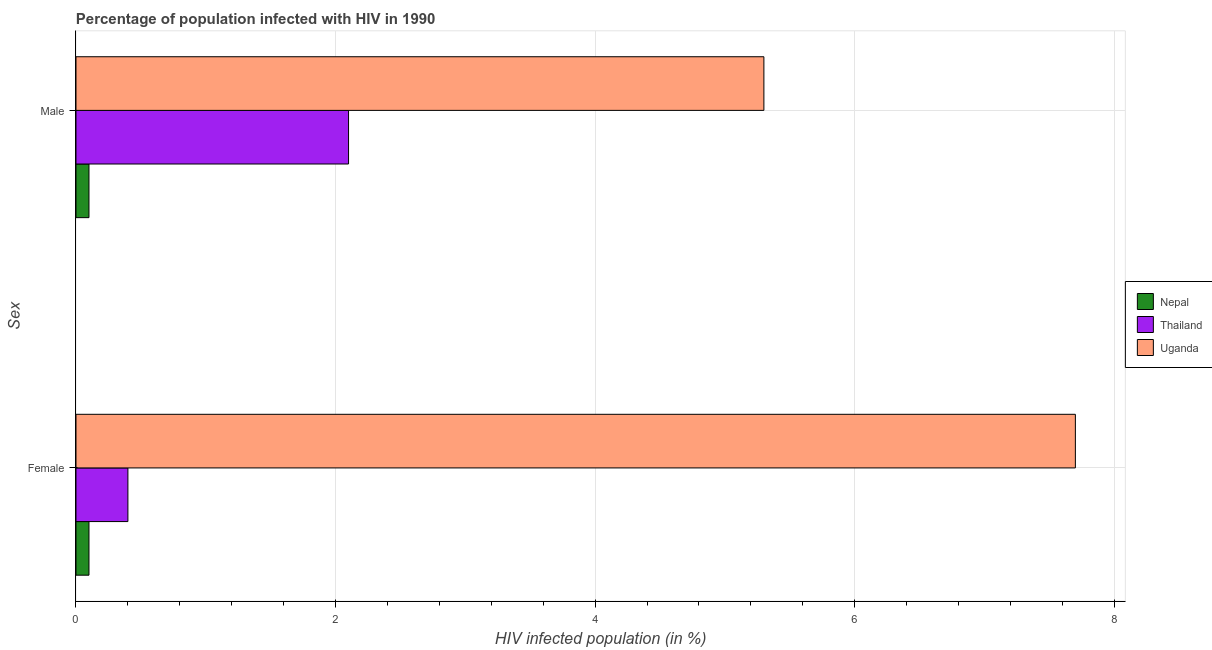What is the percentage of males who are infected with hiv in Thailand?
Your answer should be very brief. 2.1. In which country was the percentage of males who are infected with hiv maximum?
Offer a very short reply. Uganda. In which country was the percentage of females who are infected with hiv minimum?
Make the answer very short. Nepal. What is the total percentage of males who are infected with hiv in the graph?
Provide a succinct answer. 7.5. What is the difference between the percentage of males who are infected with hiv in Uganda and that in Thailand?
Provide a short and direct response. 3.2. What is the difference between the percentage of males who are infected with hiv in Nepal and the percentage of females who are infected with hiv in Uganda?
Keep it short and to the point. -7.6. What is the difference between the percentage of females who are infected with hiv and percentage of males who are infected with hiv in Uganda?
Your answer should be compact. 2.4. What is the ratio of the percentage of males who are infected with hiv in Thailand to that in Uganda?
Provide a short and direct response. 0.4. What does the 2nd bar from the top in Female represents?
Offer a terse response. Thailand. What does the 2nd bar from the bottom in Male represents?
Make the answer very short. Thailand. How many bars are there?
Keep it short and to the point. 6. What is the difference between two consecutive major ticks on the X-axis?
Provide a succinct answer. 2. Does the graph contain any zero values?
Your answer should be compact. No. Where does the legend appear in the graph?
Your response must be concise. Center right. How many legend labels are there?
Offer a terse response. 3. How are the legend labels stacked?
Keep it short and to the point. Vertical. What is the title of the graph?
Make the answer very short. Percentage of population infected with HIV in 1990. Does "Bhutan" appear as one of the legend labels in the graph?
Provide a succinct answer. No. What is the label or title of the X-axis?
Provide a succinct answer. HIV infected population (in %). What is the label or title of the Y-axis?
Offer a very short reply. Sex. What is the HIV infected population (in %) in Thailand in Female?
Offer a terse response. 0.4. What is the HIV infected population (in %) of Nepal in Male?
Provide a succinct answer. 0.1. Across all Sex, what is the maximum HIV infected population (in %) of Uganda?
Keep it short and to the point. 7.7. Across all Sex, what is the minimum HIV infected population (in %) in Thailand?
Provide a succinct answer. 0.4. What is the total HIV infected population (in %) in Thailand in the graph?
Provide a short and direct response. 2.5. What is the total HIV infected population (in %) in Uganda in the graph?
Offer a very short reply. 13. What is the difference between the HIV infected population (in %) in Nepal in Female and that in Male?
Offer a very short reply. 0. What is the difference between the HIV infected population (in %) in Thailand in Female and the HIV infected population (in %) in Uganda in Male?
Ensure brevity in your answer.  -4.9. What is the average HIV infected population (in %) in Uganda per Sex?
Keep it short and to the point. 6.5. What is the difference between the HIV infected population (in %) of Nepal and HIV infected population (in %) of Thailand in Female?
Your response must be concise. -0.3. What is the difference between the HIV infected population (in %) of Thailand and HIV infected population (in %) of Uganda in Female?
Offer a very short reply. -7.3. What is the difference between the HIV infected population (in %) of Nepal and HIV infected population (in %) of Thailand in Male?
Your answer should be compact. -2. What is the difference between the HIV infected population (in %) in Nepal and HIV infected population (in %) in Uganda in Male?
Provide a short and direct response. -5.2. What is the ratio of the HIV infected population (in %) of Nepal in Female to that in Male?
Give a very brief answer. 1. What is the ratio of the HIV infected population (in %) in Thailand in Female to that in Male?
Offer a very short reply. 0.19. What is the ratio of the HIV infected population (in %) of Uganda in Female to that in Male?
Your answer should be very brief. 1.45. What is the difference between the highest and the second highest HIV infected population (in %) of Uganda?
Offer a terse response. 2.4. What is the difference between the highest and the lowest HIV infected population (in %) of Thailand?
Provide a succinct answer. 1.7. What is the difference between the highest and the lowest HIV infected population (in %) of Uganda?
Make the answer very short. 2.4. 